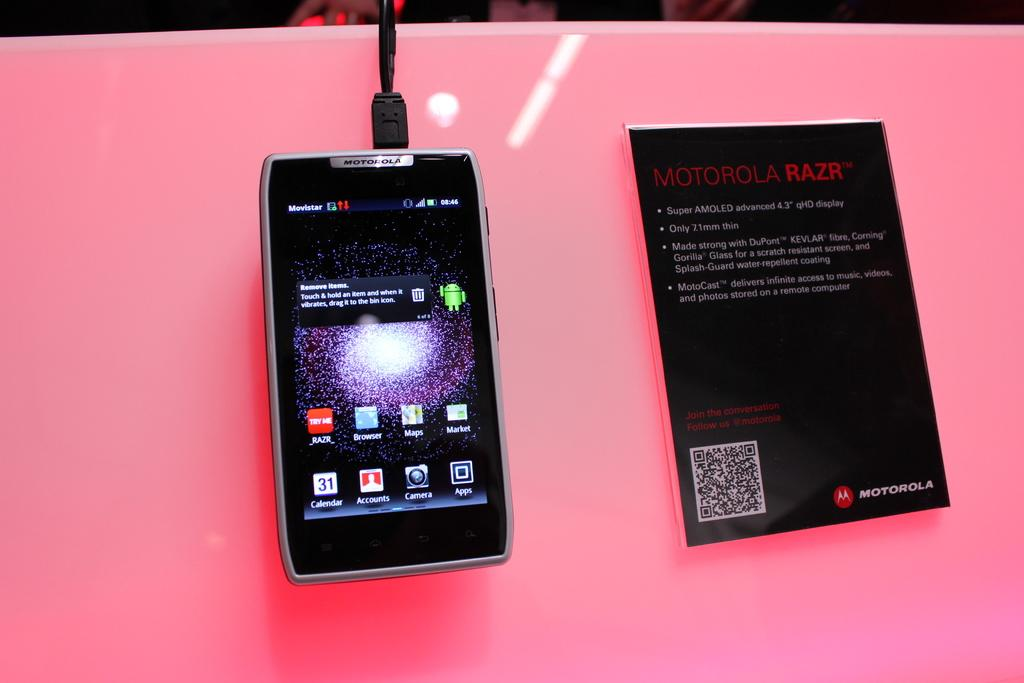<image>
Render a clear and concise summary of the photo. A Motorola device plugged in and sitting next to a Motorola info book. 